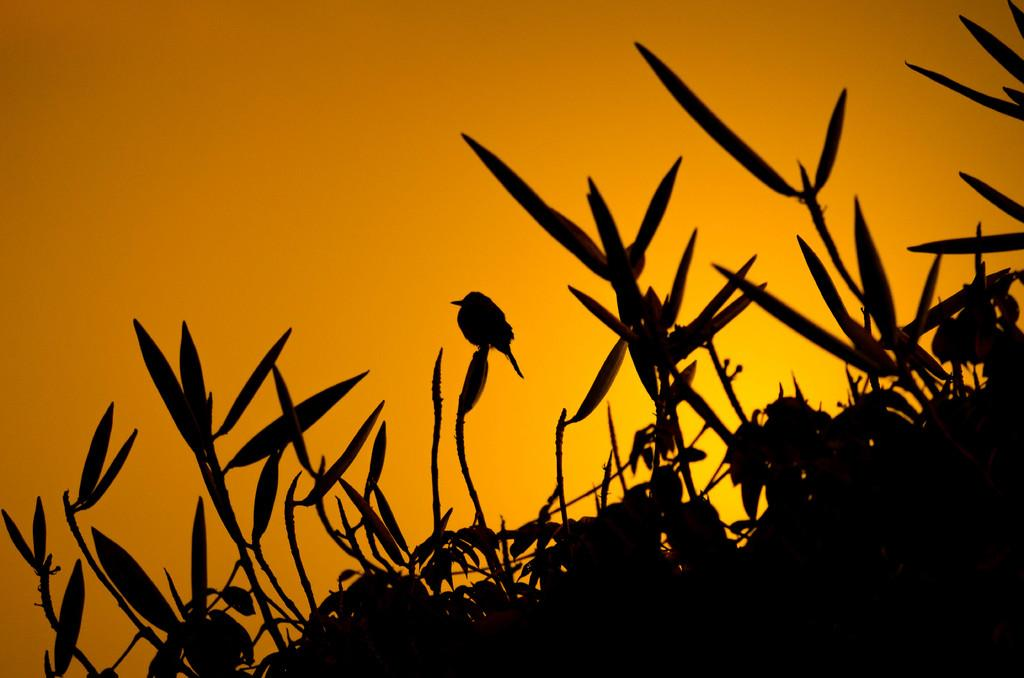What is in the foreground of the image? There are plants in the foreground of the image. What is on the plants? There is a bird on the plants. What color is the sky in the background of the image? The sky in the background of the image is orange. What type of government is depicted in the image? There is no government depicted in the image; it features plants, a bird, and an orange sky. Can you tell me how many uncles are present in the image? There are no uncles present in the image. 